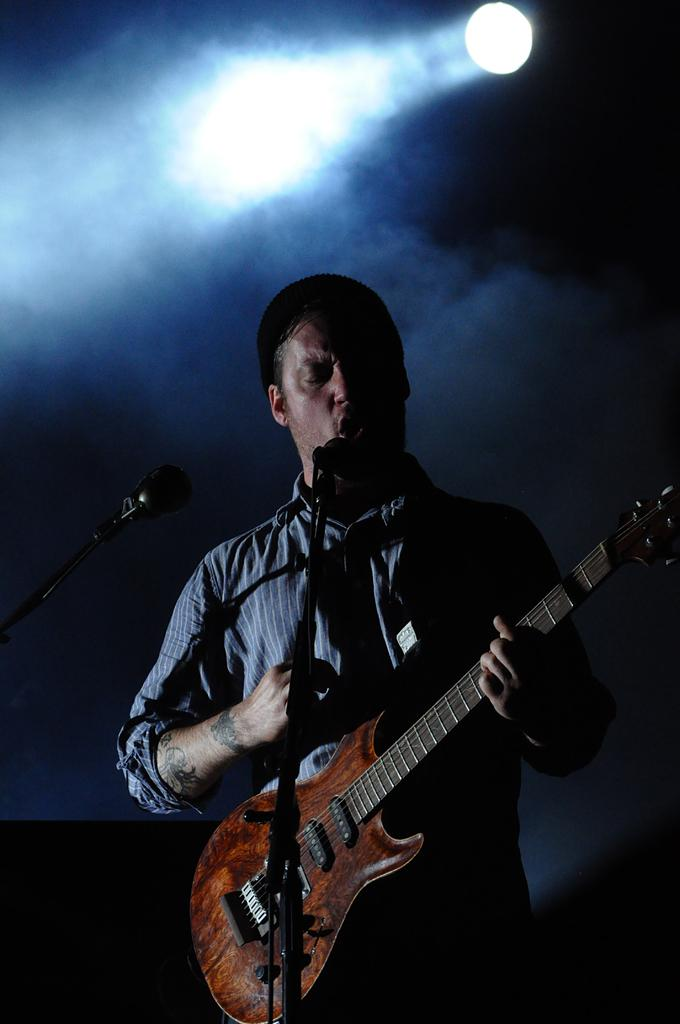Who is present in the image? There is a man in the image. What is the man holding in the image? The man is holding a guitar. What other object can be seen in the image? There is a microphone in the image. What can be used to illuminate the scene in the image? There is a light in the image. Can you see any smoke coming from the guitar in the image? There is no smoke visible in the image, and the guitar is not producing any smoke. 